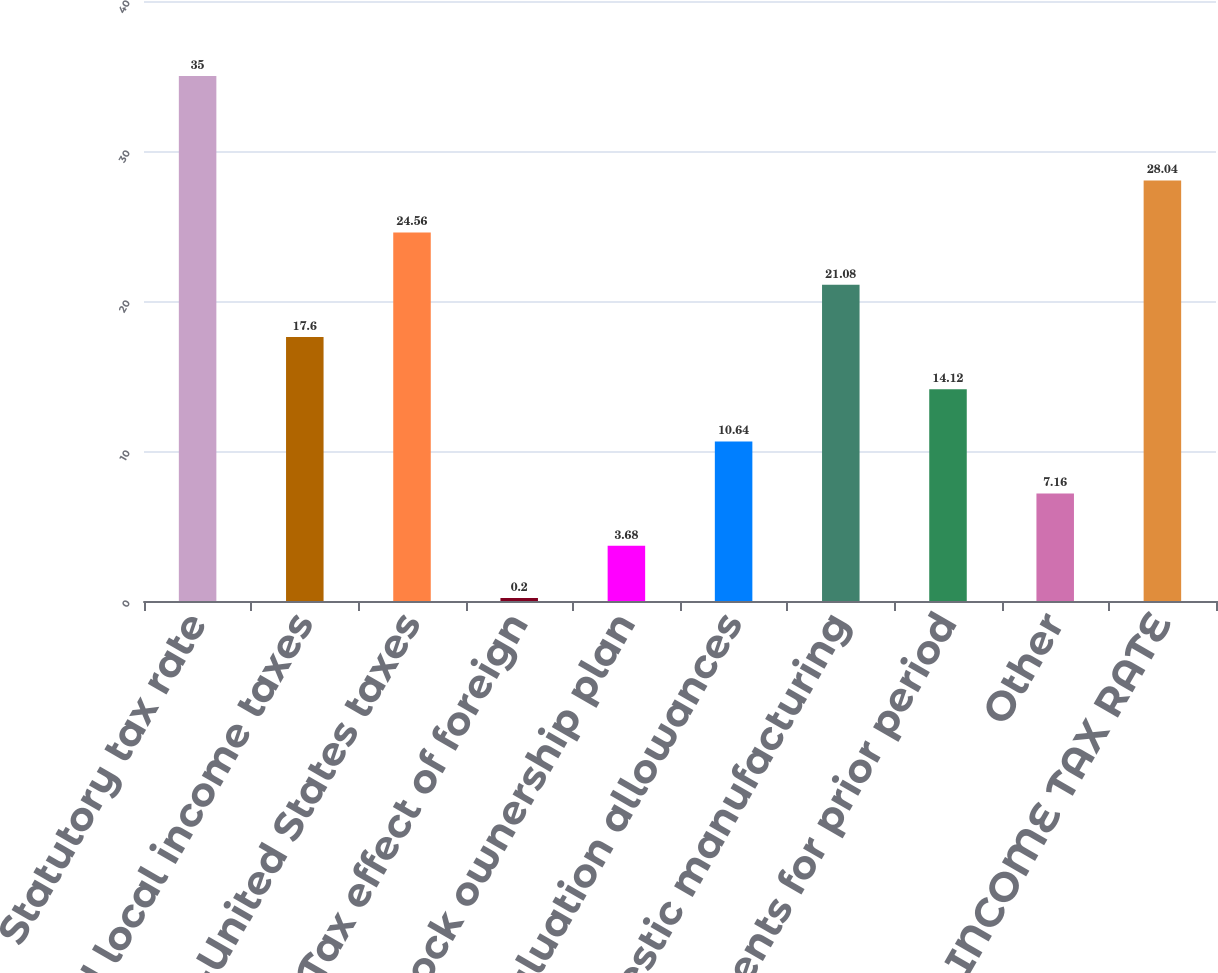Convert chart. <chart><loc_0><loc_0><loc_500><loc_500><bar_chart><fcel>Statutory tax rate<fcel>State and local income taxes<fcel>Non-United States taxes<fcel>Tax effect of foreign<fcel>Employee stock ownership plan<fcel>Change in valuation allowances<fcel>Domestic manufacturing<fcel>Adjustments for prior period<fcel>Other<fcel>EFFECTIVE INCOME TAX RATE<nl><fcel>35<fcel>17.6<fcel>24.56<fcel>0.2<fcel>3.68<fcel>10.64<fcel>21.08<fcel>14.12<fcel>7.16<fcel>28.04<nl></chart> 